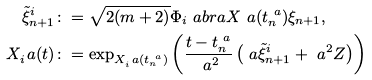<formula> <loc_0><loc_0><loc_500><loc_500>\tilde { \xi } _ { n + 1 } ^ { i } & \colon = \sqrt { 2 ( m + 2 ) } \Phi _ { i } \ a b r a { X ^ { \ } a ( t _ { n } ^ { \ a } ) } \xi _ { n + 1 } , \\ X _ { i } ^ { \ } a ( t ) & \colon = \exp _ { X _ { i } ^ { \ } a ( t _ { n } ^ { \ a } ) } \left ( \frac { t - t _ { n } ^ { \ a } } { \ a ^ { 2 } } \left ( \ a \tilde { \xi } _ { n + 1 } ^ { i } + \ a ^ { 2 } Z \right ) \right )</formula> 